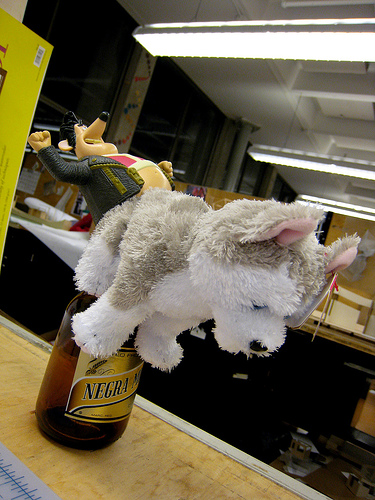<image>
Is there a stuffed animal on the bottle? Yes. Looking at the image, I can see the stuffed animal is positioned on top of the bottle, with the bottle providing support. Is there a dog in front of the mouse? Yes. The dog is positioned in front of the mouse, appearing closer to the camera viewpoint. Where is the toy dog in relation to the bottle? Is it above the bottle? Yes. The toy dog is positioned above the bottle in the vertical space, higher up in the scene. 